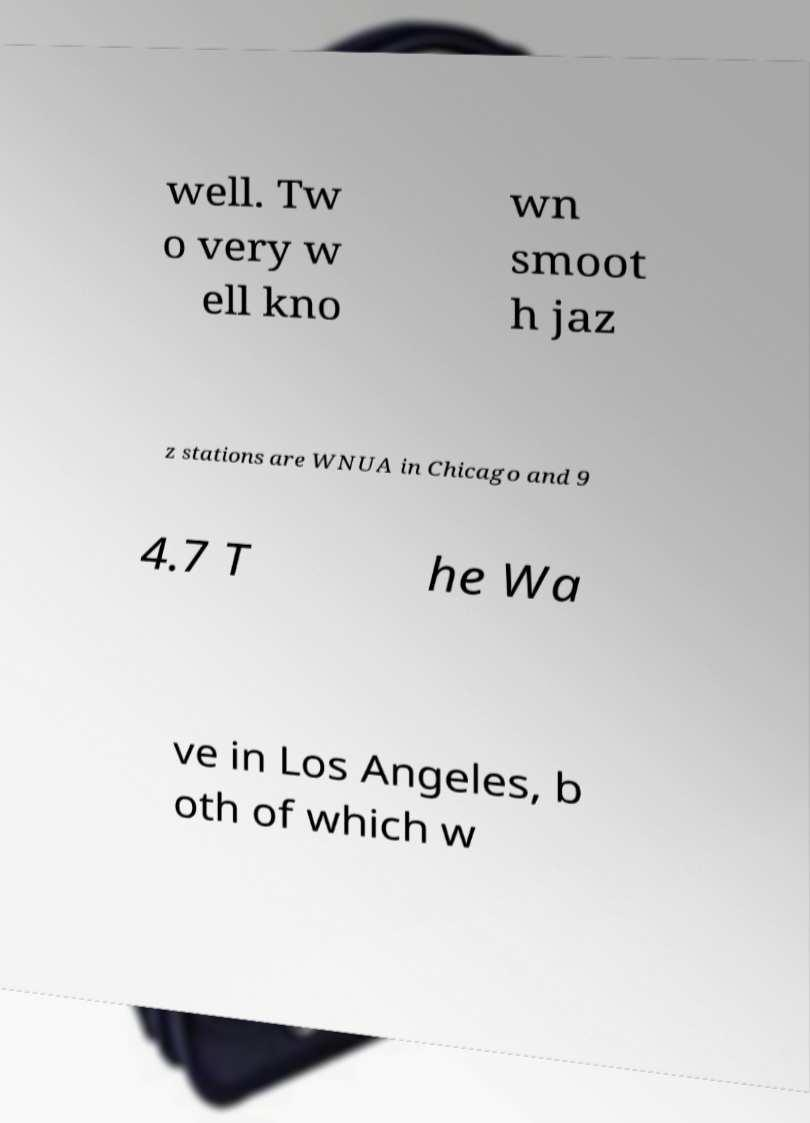Please read and relay the text visible in this image. What does it say? well. Tw o very w ell kno wn smoot h jaz z stations are WNUA in Chicago and 9 4.7 T he Wa ve in Los Angeles, b oth of which w 